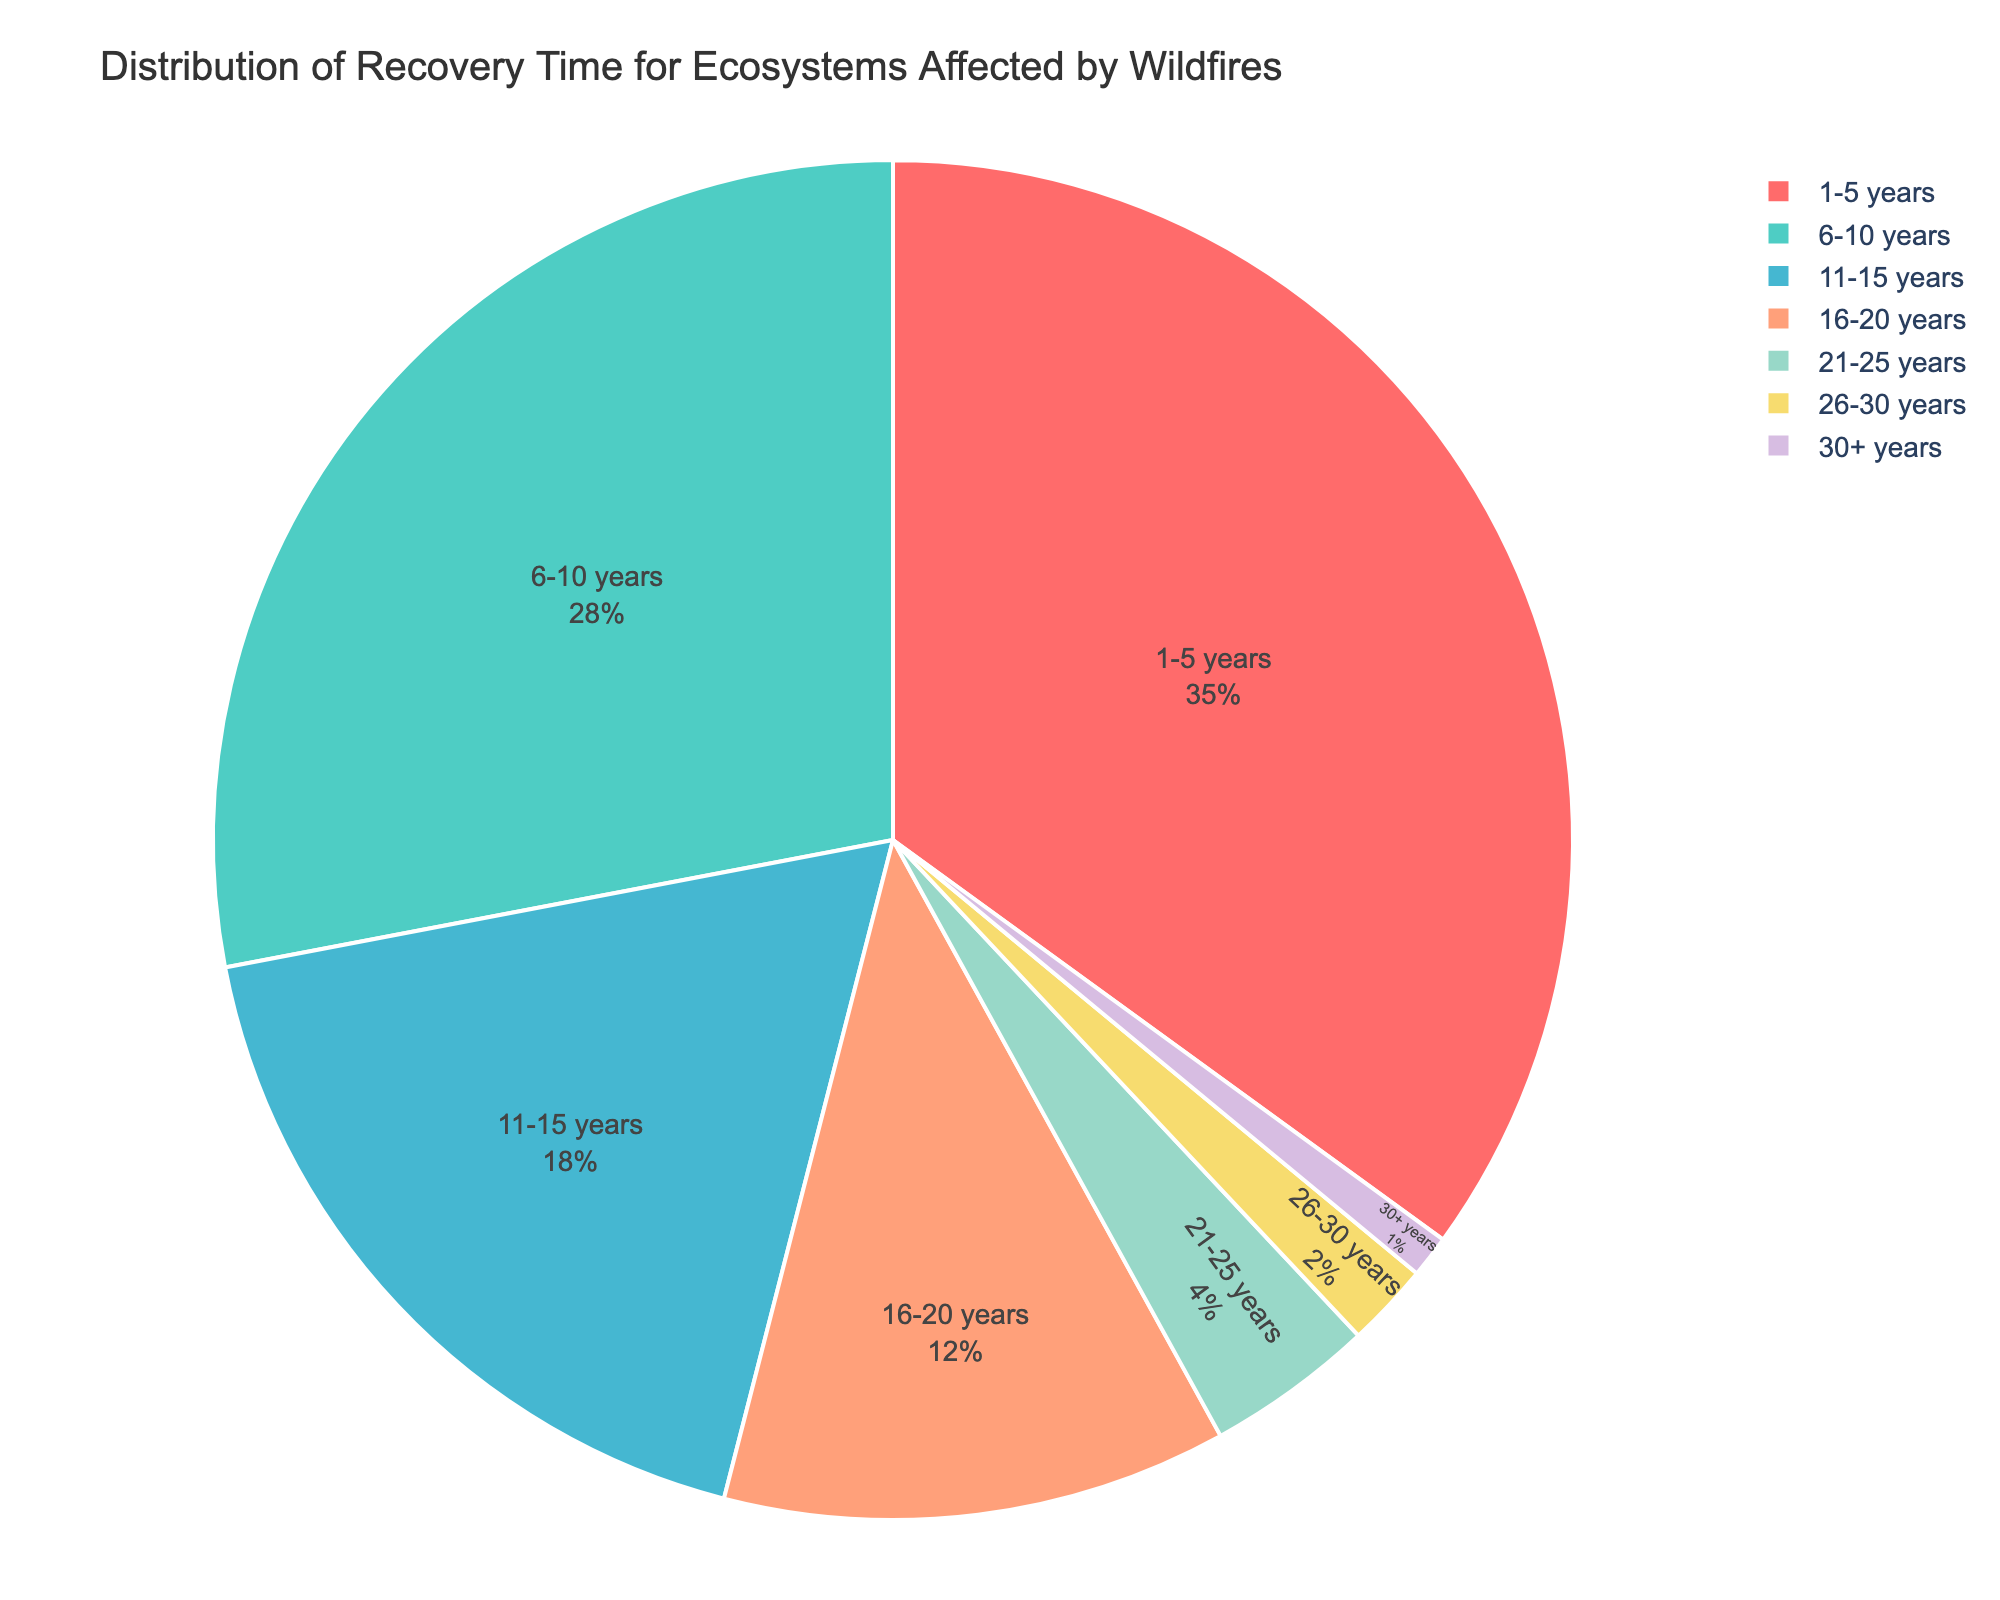What percentage of ecosystems recover in 1-5 years? The slice labeled "1-5 years" represents 35% of the pie chart, indicating that 35% of ecosystems recover within this time range.
Answer: 35% Which recovery time range has the smallest percentage? The smallest slice on the pie chart represents the "30+ years" range, which is labeled as 1%.
Answer: 1% What is the total percentage of ecosystems that recover in 20 years or less? Sum the percentages for the ranges "1-5 years" (35%), "6-10 years" (28%), "11-15 years" (18%), and "16-20 years" (12%). The total is 35% + 28% + 18% + 12% = 93%.
Answer: 93% How much larger is the percentage for 1-5 years compared to 26-30 years? Subtract the percentage for "26-30 years" (2%) from the percentage for "1-5 years" (35%). The difference is 35% - 2% = 33%.
Answer: 33% What is the combined percentage of ecosystems that take more than 20 years to recover? Sum the percentages for the ranges "21-25 years" (4%), "26-30 years" (2%), and "30+ years" (1%). The total is 4% + 2% + 1% = 7%.
Answer: 7% Which color represents the "6-10 years" range, and what percentage does it cover? The pie chart uses a custom color palette where the "6-10 years" range is represented by the color green. The percentage it covers is labeled as 28%.
Answer: Green, 28% What is the difference in recovery percentages between the 11-15 years range and the 16-20 years range? Subtract the percentage for "16-20 years" (12%) from the percentage for "11-15 years" (18%). The difference is 18% - 12% = 6%.
Answer: 6% How many recovery time ranges have a percentage of 10% or more? The ranges "1-5 years" (35%), "6-10 years" (28%), "11-15 years" (18%), and "16-20 years" (12%) all have percentages of 10% or more. In total, there are 4 such ranges.
Answer: 4 What percentage of ecosystems take less than 6 years to recover? The percentage for the "1-5 years" recovery time range is labeled as 35%, indicating that 35% of ecosystems recover in less than 6 years.
Answer: 35% Compare the percentages of ecosystems that recover in 11-15 years to those that recover in 21-25 years. The percentage for "11-15 years" is 18%, whereas the percentage for "21-25 years" is 4%. The "11-15 years" range has a higher percentage at 18% compared to 4% for "21-25 years".
Answer: 18% vs. 4% 